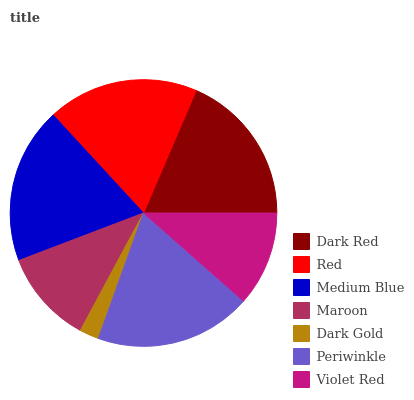Is Dark Gold the minimum?
Answer yes or no. Yes. Is Periwinkle the maximum?
Answer yes or no. Yes. Is Red the minimum?
Answer yes or no. No. Is Red the maximum?
Answer yes or no. No. Is Dark Red greater than Red?
Answer yes or no. Yes. Is Red less than Dark Red?
Answer yes or no. Yes. Is Red greater than Dark Red?
Answer yes or no. No. Is Dark Red less than Red?
Answer yes or no. No. Is Red the high median?
Answer yes or no. Yes. Is Red the low median?
Answer yes or no. Yes. Is Maroon the high median?
Answer yes or no. No. Is Dark Gold the low median?
Answer yes or no. No. 